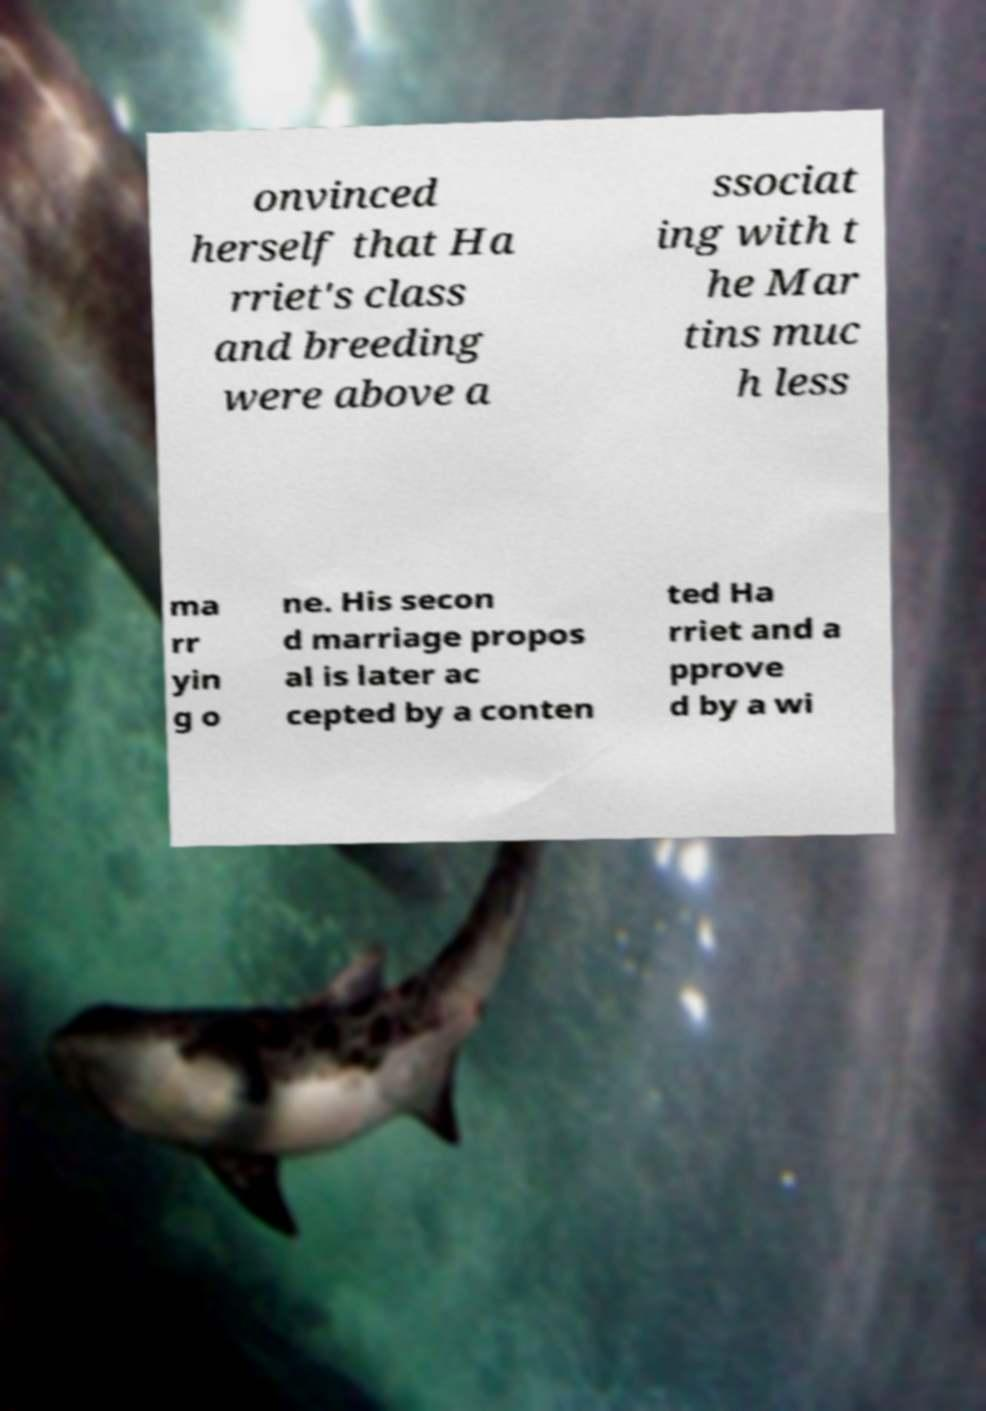What messages or text are displayed in this image? I need them in a readable, typed format. onvinced herself that Ha rriet's class and breeding were above a ssociat ing with t he Mar tins muc h less ma rr yin g o ne. His secon d marriage propos al is later ac cepted by a conten ted Ha rriet and a pprove d by a wi 